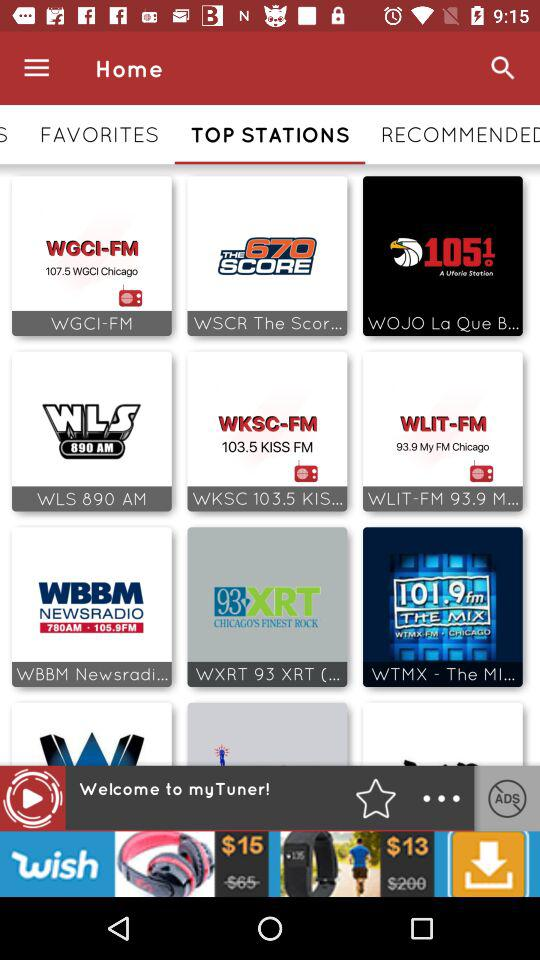What tab is currently selected? The selected tab is "TOP STATIONS". 